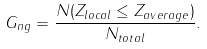Convert formula to latex. <formula><loc_0><loc_0><loc_500><loc_500>G _ { n g } = \frac { N ( Z _ { l o c a l } \leq Z _ { a v e r a g e } ) } { N _ { t o t a l } } .</formula> 